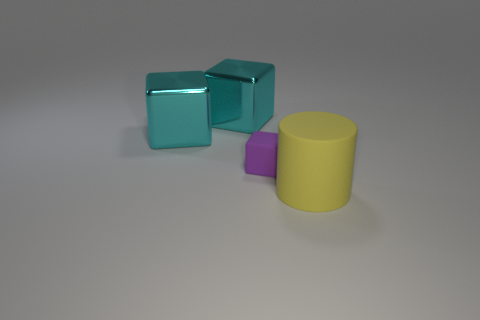What shape is the object that is in front of the tiny purple object? cylinder 